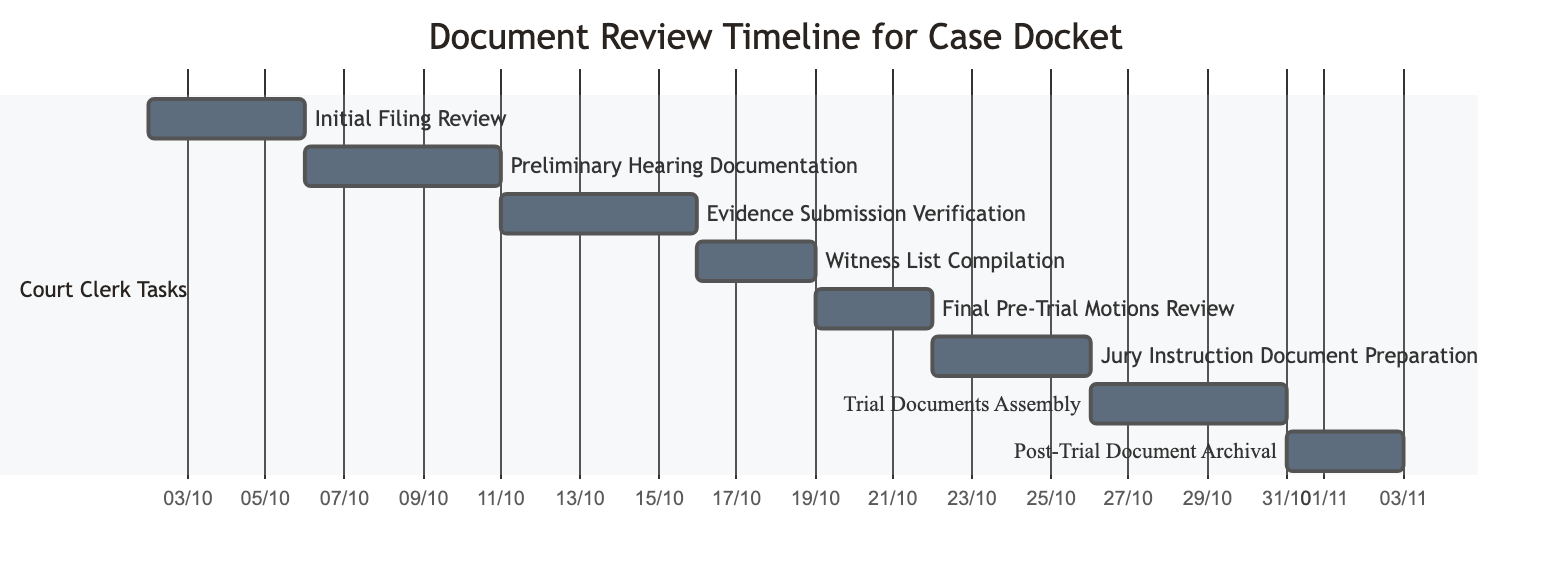What is the duration of the "Initial Filing Review" task? The "Initial Filing Review" starts on October 2 and ends on October 5, so the duration is 4 days.
Answer: 4 days Which task starts right after "Evidence Submission Verification"? The task "Witness List Compilation" starts on October 16, immediately after "Evidence Submission Verification," which ends on October 15.
Answer: Witness List Compilation How many tasks are assigned to the Court Clerk? There are a total of 8 tasks listed under the Court Clerk's responsibilities in the diagram.
Answer: 8 What is the earliest start date for any task? The earliest start date is October 2, which is when the "Initial Filing Review" begins.
Answer: October 2 Which task has the longest duration? The task with the longest duration is "Trial Documents Assembly," lasting 5 days from October 26 to October 30.
Answer: Trial Documents Assembly What is the last task in the timeline? The last task in the timeline is "Post-Trial Document Archival," which ends on November 2.
Answer: Post-Trial Document Archival How many days are allocated for "Jury Instruction Document Preparation"? "Jury Instruction Document Preparation" is allocated 4 days from October 22 to October 25.
Answer: 4 days What is the relationship between "Final Pre-Trial Motions Review" and "Trial Documents Assembly"? "Final Pre-Trial Motions Review" ends on October 21 and "Trial Documents Assembly" starts on October 26, showing a gap between these two tasks.
Answer: Gap Which task comes before "Preliminary Hearing Documentation"? The task that comes before "Preliminary Hearing Documentation" is "Initial Filing Review," which ends on October 5.
Answer: Initial Filing Review 